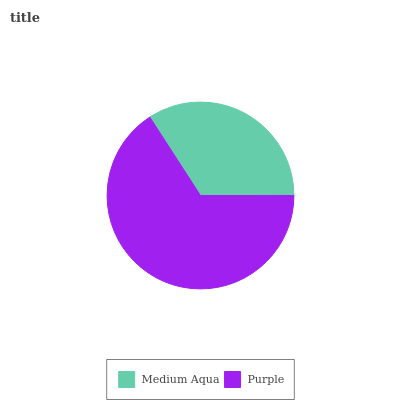Is Medium Aqua the minimum?
Answer yes or no. Yes. Is Purple the maximum?
Answer yes or no. Yes. Is Purple the minimum?
Answer yes or no. No. Is Purple greater than Medium Aqua?
Answer yes or no. Yes. Is Medium Aqua less than Purple?
Answer yes or no. Yes. Is Medium Aqua greater than Purple?
Answer yes or no. No. Is Purple less than Medium Aqua?
Answer yes or no. No. Is Purple the high median?
Answer yes or no. Yes. Is Medium Aqua the low median?
Answer yes or no. Yes. Is Medium Aqua the high median?
Answer yes or no. No. Is Purple the low median?
Answer yes or no. No. 